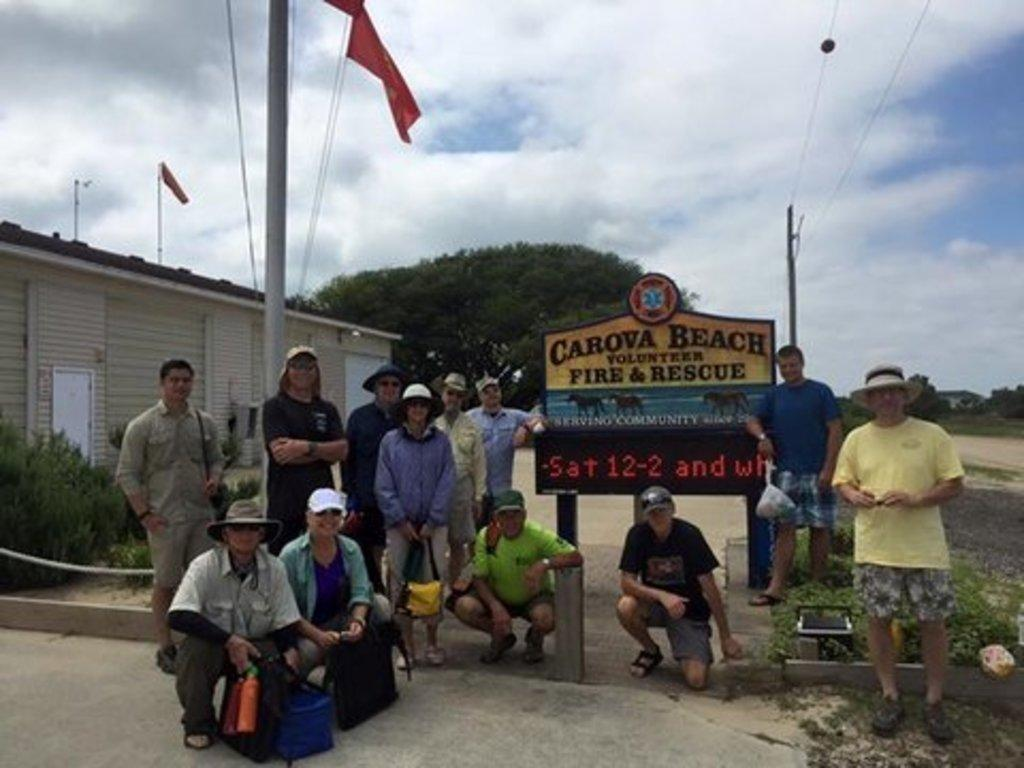What type of structure can be seen in the image? There is a house in the image. What decorative elements are present in the image? There are flags in the image. What objects are supporting the flags? There are poles in the image. What is connected to the poles? There are wires in the image. What type of vegetation is visible in the image? There are trees, plants, and grass in the image. What might be used for displaying information or announcements? There is a text board in the image. Are there any people present in the image? Yes, there are people in the image. What type of pathway is visible in the image? There is a path in the image. What can be seen in the sky in the image? The sky is visible in the image, and there are clouds in the sky. How many giraffes are standing on the path in the image? There are no giraffes present in the image. What type of balls can be seen bouncing on the grass in the image? There are no balls visible in the image. 